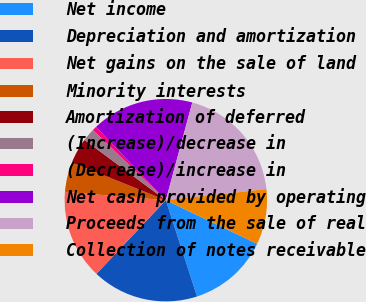Convert chart. <chart><loc_0><loc_0><loc_500><loc_500><pie_chart><fcel>Net income<fcel>Depreciation and amortization<fcel>Net gains on the sale of land<fcel>Minority interests<fcel>Amortization of deferred<fcel>(Increase)/decrease in<fcel>(Decrease)/increase in<fcel>Net cash provided by operating<fcel>Proceeds from the sale of real<fcel>Collection of notes receivable<nl><fcel>12.92%<fcel>17.0%<fcel>14.28%<fcel>4.76%<fcel>4.08%<fcel>2.05%<fcel>0.69%<fcel>16.32%<fcel>19.04%<fcel>8.84%<nl></chart> 